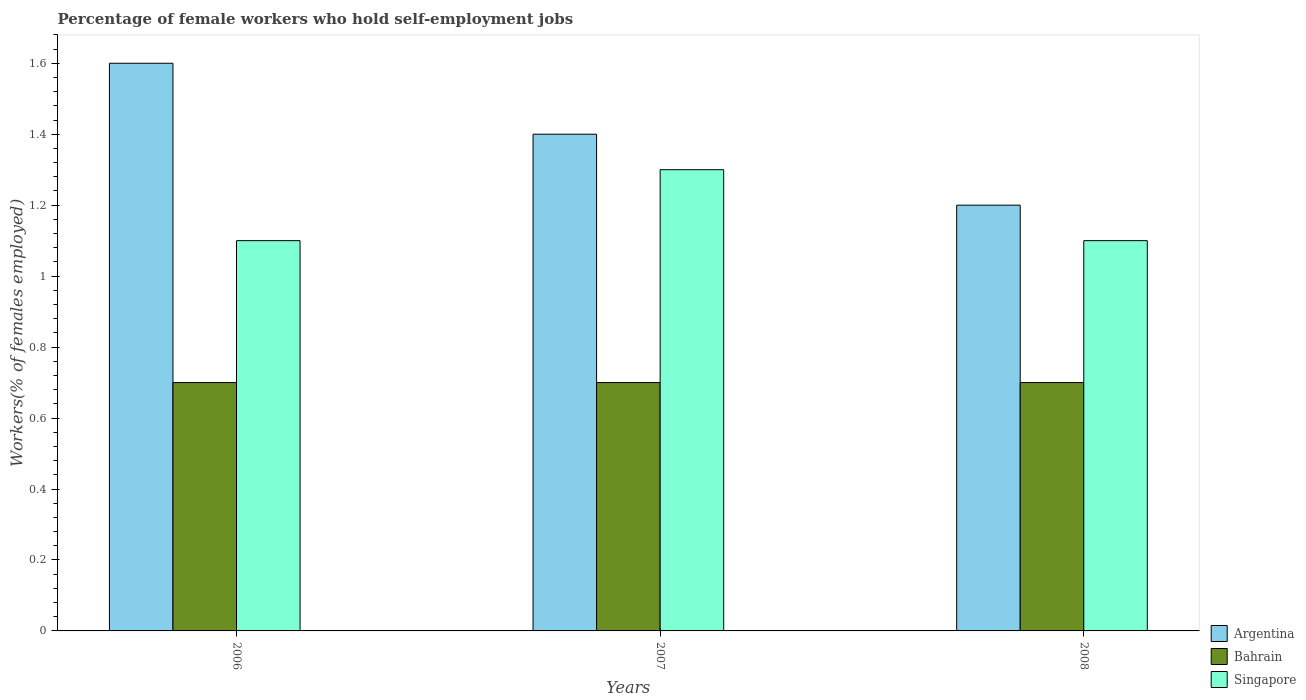How many groups of bars are there?
Your response must be concise. 3. What is the label of the 1st group of bars from the left?
Give a very brief answer. 2006. What is the percentage of self-employed female workers in Bahrain in 2006?
Give a very brief answer. 0.7. Across all years, what is the maximum percentage of self-employed female workers in Singapore?
Offer a terse response. 1.3. Across all years, what is the minimum percentage of self-employed female workers in Singapore?
Your response must be concise. 1.1. In which year was the percentage of self-employed female workers in Singapore minimum?
Ensure brevity in your answer.  2006. What is the total percentage of self-employed female workers in Bahrain in the graph?
Your answer should be compact. 2.1. What is the difference between the percentage of self-employed female workers in Argentina in 2007 and the percentage of self-employed female workers in Singapore in 2008?
Make the answer very short. 0.3. What is the average percentage of self-employed female workers in Bahrain per year?
Offer a terse response. 0.7. In the year 2007, what is the difference between the percentage of self-employed female workers in Argentina and percentage of self-employed female workers in Singapore?
Your response must be concise. 0.1. What is the ratio of the percentage of self-employed female workers in Singapore in 2007 to that in 2008?
Offer a very short reply. 1.18. Is the percentage of self-employed female workers in Bahrain in 2006 less than that in 2007?
Make the answer very short. No. What is the difference between the highest and the second highest percentage of self-employed female workers in Singapore?
Keep it short and to the point. 0.2. What is the difference between the highest and the lowest percentage of self-employed female workers in Singapore?
Offer a terse response. 0.2. What does the 2nd bar from the right in 2006 represents?
Offer a very short reply. Bahrain. How many years are there in the graph?
Offer a very short reply. 3. What is the title of the graph?
Your response must be concise. Percentage of female workers who hold self-employment jobs. Does "Thailand" appear as one of the legend labels in the graph?
Offer a very short reply. No. What is the label or title of the Y-axis?
Offer a very short reply. Workers(% of females employed). What is the Workers(% of females employed) of Argentina in 2006?
Ensure brevity in your answer.  1.6. What is the Workers(% of females employed) in Bahrain in 2006?
Offer a very short reply. 0.7. What is the Workers(% of females employed) of Singapore in 2006?
Your response must be concise. 1.1. What is the Workers(% of females employed) in Argentina in 2007?
Your answer should be compact. 1.4. What is the Workers(% of females employed) of Bahrain in 2007?
Offer a very short reply. 0.7. What is the Workers(% of females employed) of Singapore in 2007?
Give a very brief answer. 1.3. What is the Workers(% of females employed) in Argentina in 2008?
Keep it short and to the point. 1.2. What is the Workers(% of females employed) of Bahrain in 2008?
Offer a terse response. 0.7. What is the Workers(% of females employed) in Singapore in 2008?
Your response must be concise. 1.1. Across all years, what is the maximum Workers(% of females employed) in Argentina?
Your answer should be compact. 1.6. Across all years, what is the maximum Workers(% of females employed) of Bahrain?
Provide a succinct answer. 0.7. Across all years, what is the maximum Workers(% of females employed) of Singapore?
Provide a succinct answer. 1.3. Across all years, what is the minimum Workers(% of females employed) in Argentina?
Offer a terse response. 1.2. Across all years, what is the minimum Workers(% of females employed) in Bahrain?
Keep it short and to the point. 0.7. Across all years, what is the minimum Workers(% of females employed) in Singapore?
Ensure brevity in your answer.  1.1. What is the total Workers(% of females employed) of Argentina in the graph?
Your response must be concise. 4.2. What is the total Workers(% of females employed) in Bahrain in the graph?
Your response must be concise. 2.1. What is the total Workers(% of females employed) in Singapore in the graph?
Your answer should be very brief. 3.5. What is the difference between the Workers(% of females employed) of Argentina in 2006 and that in 2007?
Ensure brevity in your answer.  0.2. What is the difference between the Workers(% of females employed) of Singapore in 2006 and that in 2007?
Offer a terse response. -0.2. What is the difference between the Workers(% of females employed) in Argentina in 2006 and that in 2008?
Ensure brevity in your answer.  0.4. What is the difference between the Workers(% of females employed) in Bahrain in 2006 and that in 2008?
Offer a very short reply. 0. What is the difference between the Workers(% of females employed) of Singapore in 2006 and that in 2008?
Make the answer very short. 0. What is the difference between the Workers(% of females employed) in Argentina in 2006 and the Workers(% of females employed) in Singapore in 2007?
Provide a succinct answer. 0.3. What is the difference between the Workers(% of females employed) of Bahrain in 2006 and the Workers(% of females employed) of Singapore in 2007?
Your answer should be compact. -0.6. What is the difference between the Workers(% of females employed) of Argentina in 2006 and the Workers(% of females employed) of Bahrain in 2008?
Your response must be concise. 0.9. What is the difference between the Workers(% of females employed) of Argentina in 2006 and the Workers(% of females employed) of Singapore in 2008?
Ensure brevity in your answer.  0.5. What is the difference between the Workers(% of females employed) in Argentina in 2007 and the Workers(% of females employed) in Bahrain in 2008?
Ensure brevity in your answer.  0.7. What is the difference between the Workers(% of females employed) of Bahrain in 2007 and the Workers(% of females employed) of Singapore in 2008?
Offer a terse response. -0.4. What is the average Workers(% of females employed) in Argentina per year?
Your answer should be very brief. 1.4. What is the average Workers(% of females employed) of Bahrain per year?
Your answer should be very brief. 0.7. What is the average Workers(% of females employed) of Singapore per year?
Keep it short and to the point. 1.17. In the year 2006, what is the difference between the Workers(% of females employed) of Argentina and Workers(% of females employed) of Bahrain?
Give a very brief answer. 0.9. In the year 2007, what is the difference between the Workers(% of females employed) in Argentina and Workers(% of females employed) in Bahrain?
Your response must be concise. 0.7. In the year 2007, what is the difference between the Workers(% of females employed) of Argentina and Workers(% of females employed) of Singapore?
Your answer should be compact. 0.1. In the year 2008, what is the difference between the Workers(% of females employed) in Argentina and Workers(% of females employed) in Bahrain?
Provide a succinct answer. 0.5. What is the ratio of the Workers(% of females employed) of Bahrain in 2006 to that in 2007?
Give a very brief answer. 1. What is the ratio of the Workers(% of females employed) of Singapore in 2006 to that in 2007?
Your answer should be compact. 0.85. What is the ratio of the Workers(% of females employed) of Argentina in 2006 to that in 2008?
Your answer should be very brief. 1.33. What is the ratio of the Workers(% of females employed) of Bahrain in 2006 to that in 2008?
Your answer should be very brief. 1. What is the ratio of the Workers(% of females employed) in Singapore in 2006 to that in 2008?
Provide a succinct answer. 1. What is the ratio of the Workers(% of females employed) in Argentina in 2007 to that in 2008?
Your answer should be very brief. 1.17. What is the ratio of the Workers(% of females employed) of Singapore in 2007 to that in 2008?
Provide a succinct answer. 1.18. What is the difference between the highest and the second highest Workers(% of females employed) in Argentina?
Your answer should be very brief. 0.2. What is the difference between the highest and the second highest Workers(% of females employed) of Bahrain?
Your response must be concise. 0. What is the difference between the highest and the second highest Workers(% of females employed) of Singapore?
Your answer should be very brief. 0.2. What is the difference between the highest and the lowest Workers(% of females employed) in Argentina?
Provide a succinct answer. 0.4. What is the difference between the highest and the lowest Workers(% of females employed) of Bahrain?
Your answer should be compact. 0. What is the difference between the highest and the lowest Workers(% of females employed) of Singapore?
Ensure brevity in your answer.  0.2. 